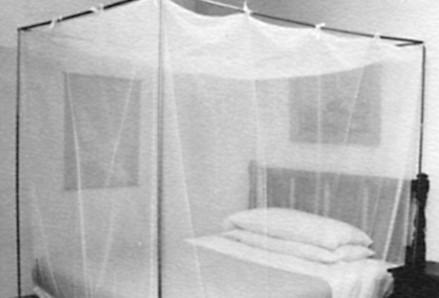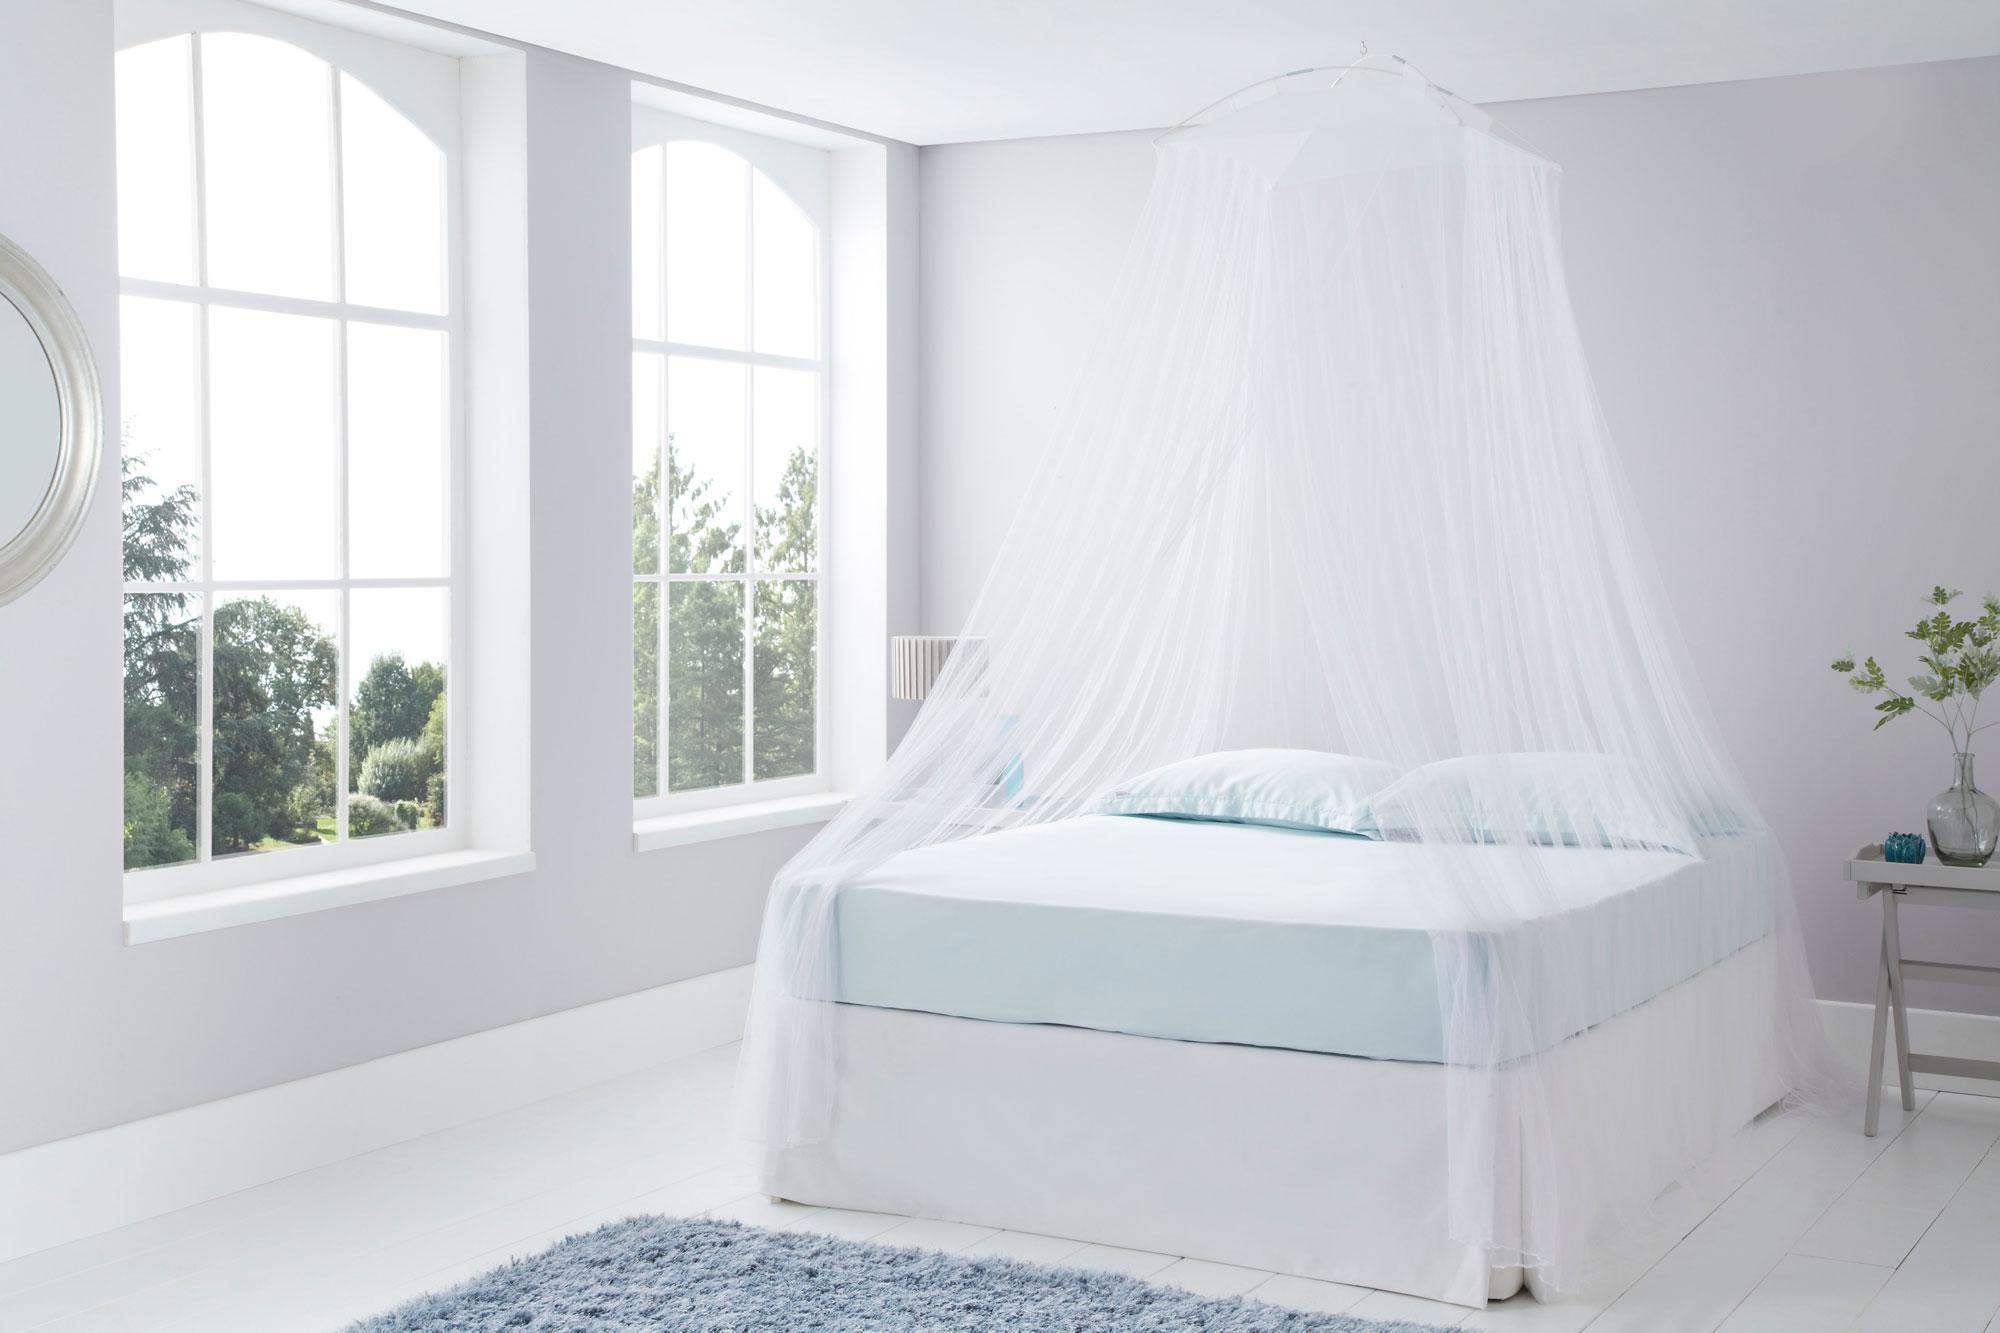The first image is the image on the left, the second image is the image on the right. For the images shown, is this caption "One image shows a ceiling-suspended gauzy white canopy that hangs over the middle of a bed in a cone shape that extends around most of the bed." true? Answer yes or no. Yes. The first image is the image on the left, the second image is the image on the right. Evaluate the accuracy of this statement regarding the images: "In at least one image there is a squared canopy with two of the lace curtains tied to the end of the bed poles.". Is it true? Answer yes or no. No. 